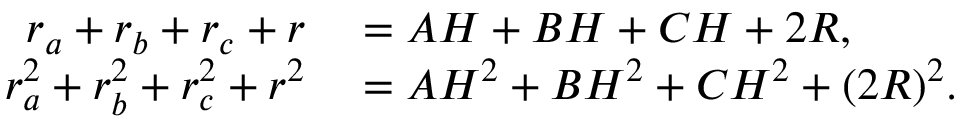<formula> <loc_0><loc_0><loc_500><loc_500>\begin{array} { r l } { r _ { a } + r _ { b } + r _ { c } + r } & = A H + B H + C H + 2 R , } \\ { r _ { a } ^ { 2 } + r _ { b } ^ { 2 } + r _ { c } ^ { 2 } + r ^ { 2 } } & = A H ^ { 2 } + B H ^ { 2 } + C H ^ { 2 } + ( 2 R ) ^ { 2 } . } \end{array}</formula> 